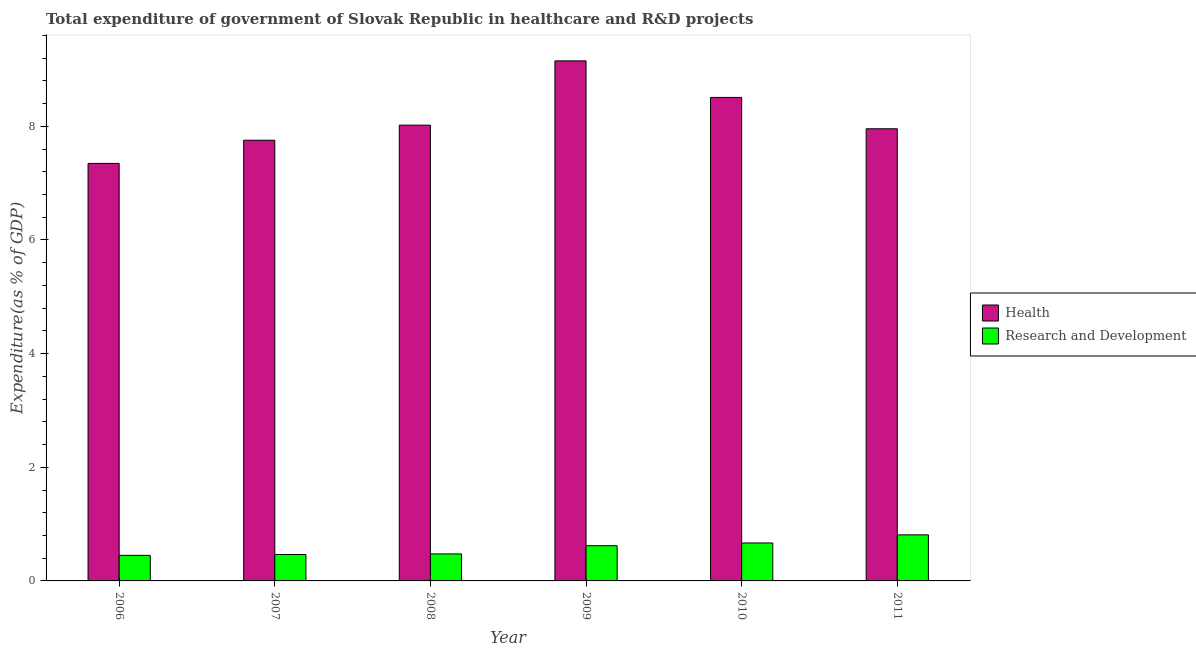How many groups of bars are there?
Offer a very short reply. 6. Are the number of bars on each tick of the X-axis equal?
Offer a very short reply. Yes. How many bars are there on the 2nd tick from the right?
Offer a terse response. 2. What is the label of the 4th group of bars from the left?
Give a very brief answer. 2009. In how many cases, is the number of bars for a given year not equal to the number of legend labels?
Keep it short and to the point. 0. What is the expenditure in healthcare in 2010?
Provide a succinct answer. 8.51. Across all years, what is the maximum expenditure in r&d?
Provide a succinct answer. 0.81. Across all years, what is the minimum expenditure in r&d?
Your answer should be compact. 0.45. In which year was the expenditure in healthcare maximum?
Provide a succinct answer. 2009. In which year was the expenditure in healthcare minimum?
Provide a succinct answer. 2006. What is the total expenditure in healthcare in the graph?
Ensure brevity in your answer.  48.74. What is the difference between the expenditure in r&d in 2007 and that in 2010?
Ensure brevity in your answer.  -0.2. What is the difference between the expenditure in healthcare in 2010 and the expenditure in r&d in 2006?
Offer a very short reply. 1.16. What is the average expenditure in healthcare per year?
Make the answer very short. 8.12. In the year 2009, what is the difference between the expenditure in healthcare and expenditure in r&d?
Ensure brevity in your answer.  0. What is the ratio of the expenditure in r&d in 2007 to that in 2011?
Keep it short and to the point. 0.57. Is the difference between the expenditure in healthcare in 2008 and 2010 greater than the difference between the expenditure in r&d in 2008 and 2010?
Your answer should be compact. No. What is the difference between the highest and the second highest expenditure in healthcare?
Give a very brief answer. 0.64. What is the difference between the highest and the lowest expenditure in healthcare?
Provide a short and direct response. 1.8. In how many years, is the expenditure in healthcare greater than the average expenditure in healthcare taken over all years?
Your answer should be compact. 2. What does the 1st bar from the left in 2008 represents?
Offer a terse response. Health. What does the 1st bar from the right in 2009 represents?
Give a very brief answer. Research and Development. How many bars are there?
Ensure brevity in your answer.  12. Are all the bars in the graph horizontal?
Offer a terse response. No. How many years are there in the graph?
Your response must be concise. 6. Does the graph contain any zero values?
Your answer should be compact. No. Where does the legend appear in the graph?
Your answer should be compact. Center right. How many legend labels are there?
Your response must be concise. 2. How are the legend labels stacked?
Your answer should be compact. Vertical. What is the title of the graph?
Keep it short and to the point. Total expenditure of government of Slovak Republic in healthcare and R&D projects. What is the label or title of the X-axis?
Keep it short and to the point. Year. What is the label or title of the Y-axis?
Your answer should be very brief. Expenditure(as % of GDP). What is the Expenditure(as % of GDP) of Health in 2006?
Provide a short and direct response. 7.35. What is the Expenditure(as % of GDP) of Research and Development in 2006?
Offer a very short reply. 0.45. What is the Expenditure(as % of GDP) in Health in 2007?
Ensure brevity in your answer.  7.76. What is the Expenditure(as % of GDP) in Research and Development in 2007?
Give a very brief answer. 0.46. What is the Expenditure(as % of GDP) in Health in 2008?
Offer a terse response. 8.02. What is the Expenditure(as % of GDP) of Research and Development in 2008?
Your answer should be very brief. 0.47. What is the Expenditure(as % of GDP) of Health in 2009?
Give a very brief answer. 9.15. What is the Expenditure(as % of GDP) of Research and Development in 2009?
Offer a terse response. 0.62. What is the Expenditure(as % of GDP) of Health in 2010?
Your answer should be very brief. 8.51. What is the Expenditure(as % of GDP) of Research and Development in 2010?
Your answer should be very brief. 0.67. What is the Expenditure(as % of GDP) in Health in 2011?
Your response must be concise. 7.96. What is the Expenditure(as % of GDP) of Research and Development in 2011?
Give a very brief answer. 0.81. Across all years, what is the maximum Expenditure(as % of GDP) of Health?
Your answer should be compact. 9.15. Across all years, what is the maximum Expenditure(as % of GDP) in Research and Development?
Your answer should be compact. 0.81. Across all years, what is the minimum Expenditure(as % of GDP) of Health?
Ensure brevity in your answer.  7.35. Across all years, what is the minimum Expenditure(as % of GDP) in Research and Development?
Give a very brief answer. 0.45. What is the total Expenditure(as % of GDP) of Health in the graph?
Offer a terse response. 48.74. What is the total Expenditure(as % of GDP) of Research and Development in the graph?
Provide a succinct answer. 3.49. What is the difference between the Expenditure(as % of GDP) of Health in 2006 and that in 2007?
Give a very brief answer. -0.41. What is the difference between the Expenditure(as % of GDP) of Research and Development in 2006 and that in 2007?
Ensure brevity in your answer.  -0.01. What is the difference between the Expenditure(as % of GDP) of Health in 2006 and that in 2008?
Ensure brevity in your answer.  -0.67. What is the difference between the Expenditure(as % of GDP) in Research and Development in 2006 and that in 2008?
Keep it short and to the point. -0.03. What is the difference between the Expenditure(as % of GDP) of Health in 2006 and that in 2009?
Your answer should be very brief. -1.8. What is the difference between the Expenditure(as % of GDP) of Research and Development in 2006 and that in 2009?
Your response must be concise. -0.17. What is the difference between the Expenditure(as % of GDP) in Health in 2006 and that in 2010?
Make the answer very short. -1.16. What is the difference between the Expenditure(as % of GDP) in Research and Development in 2006 and that in 2010?
Your response must be concise. -0.22. What is the difference between the Expenditure(as % of GDP) of Health in 2006 and that in 2011?
Ensure brevity in your answer.  -0.61. What is the difference between the Expenditure(as % of GDP) of Research and Development in 2006 and that in 2011?
Keep it short and to the point. -0.36. What is the difference between the Expenditure(as % of GDP) in Health in 2007 and that in 2008?
Keep it short and to the point. -0.27. What is the difference between the Expenditure(as % of GDP) of Research and Development in 2007 and that in 2008?
Provide a short and direct response. -0.01. What is the difference between the Expenditure(as % of GDP) in Health in 2007 and that in 2009?
Your answer should be compact. -1.4. What is the difference between the Expenditure(as % of GDP) in Research and Development in 2007 and that in 2009?
Your answer should be compact. -0.16. What is the difference between the Expenditure(as % of GDP) in Health in 2007 and that in 2010?
Give a very brief answer. -0.75. What is the difference between the Expenditure(as % of GDP) of Research and Development in 2007 and that in 2010?
Ensure brevity in your answer.  -0.2. What is the difference between the Expenditure(as % of GDP) of Health in 2007 and that in 2011?
Your response must be concise. -0.2. What is the difference between the Expenditure(as % of GDP) of Research and Development in 2007 and that in 2011?
Make the answer very short. -0.35. What is the difference between the Expenditure(as % of GDP) in Health in 2008 and that in 2009?
Give a very brief answer. -1.13. What is the difference between the Expenditure(as % of GDP) of Research and Development in 2008 and that in 2009?
Give a very brief answer. -0.14. What is the difference between the Expenditure(as % of GDP) of Health in 2008 and that in 2010?
Provide a short and direct response. -0.49. What is the difference between the Expenditure(as % of GDP) of Research and Development in 2008 and that in 2010?
Your answer should be compact. -0.19. What is the difference between the Expenditure(as % of GDP) in Health in 2008 and that in 2011?
Provide a succinct answer. 0.06. What is the difference between the Expenditure(as % of GDP) in Research and Development in 2008 and that in 2011?
Provide a succinct answer. -0.34. What is the difference between the Expenditure(as % of GDP) in Health in 2009 and that in 2010?
Provide a short and direct response. 0.64. What is the difference between the Expenditure(as % of GDP) of Research and Development in 2009 and that in 2010?
Ensure brevity in your answer.  -0.05. What is the difference between the Expenditure(as % of GDP) in Health in 2009 and that in 2011?
Offer a terse response. 1.19. What is the difference between the Expenditure(as % of GDP) of Research and Development in 2009 and that in 2011?
Make the answer very short. -0.19. What is the difference between the Expenditure(as % of GDP) of Health in 2010 and that in 2011?
Make the answer very short. 0.55. What is the difference between the Expenditure(as % of GDP) of Research and Development in 2010 and that in 2011?
Ensure brevity in your answer.  -0.14. What is the difference between the Expenditure(as % of GDP) in Health in 2006 and the Expenditure(as % of GDP) in Research and Development in 2007?
Provide a succinct answer. 6.88. What is the difference between the Expenditure(as % of GDP) of Health in 2006 and the Expenditure(as % of GDP) of Research and Development in 2008?
Your response must be concise. 6.87. What is the difference between the Expenditure(as % of GDP) in Health in 2006 and the Expenditure(as % of GDP) in Research and Development in 2009?
Your response must be concise. 6.73. What is the difference between the Expenditure(as % of GDP) in Health in 2006 and the Expenditure(as % of GDP) in Research and Development in 2010?
Give a very brief answer. 6.68. What is the difference between the Expenditure(as % of GDP) of Health in 2006 and the Expenditure(as % of GDP) of Research and Development in 2011?
Keep it short and to the point. 6.54. What is the difference between the Expenditure(as % of GDP) of Health in 2007 and the Expenditure(as % of GDP) of Research and Development in 2008?
Your response must be concise. 7.28. What is the difference between the Expenditure(as % of GDP) in Health in 2007 and the Expenditure(as % of GDP) in Research and Development in 2009?
Your answer should be very brief. 7.14. What is the difference between the Expenditure(as % of GDP) in Health in 2007 and the Expenditure(as % of GDP) in Research and Development in 2010?
Provide a short and direct response. 7.09. What is the difference between the Expenditure(as % of GDP) in Health in 2007 and the Expenditure(as % of GDP) in Research and Development in 2011?
Your answer should be compact. 6.94. What is the difference between the Expenditure(as % of GDP) of Health in 2008 and the Expenditure(as % of GDP) of Research and Development in 2009?
Ensure brevity in your answer.  7.4. What is the difference between the Expenditure(as % of GDP) of Health in 2008 and the Expenditure(as % of GDP) of Research and Development in 2010?
Keep it short and to the point. 7.35. What is the difference between the Expenditure(as % of GDP) of Health in 2008 and the Expenditure(as % of GDP) of Research and Development in 2011?
Give a very brief answer. 7.21. What is the difference between the Expenditure(as % of GDP) in Health in 2009 and the Expenditure(as % of GDP) in Research and Development in 2010?
Your response must be concise. 8.48. What is the difference between the Expenditure(as % of GDP) in Health in 2009 and the Expenditure(as % of GDP) in Research and Development in 2011?
Offer a terse response. 8.34. What is the difference between the Expenditure(as % of GDP) of Health in 2010 and the Expenditure(as % of GDP) of Research and Development in 2011?
Your response must be concise. 7.7. What is the average Expenditure(as % of GDP) in Health per year?
Offer a terse response. 8.12. What is the average Expenditure(as % of GDP) in Research and Development per year?
Give a very brief answer. 0.58. In the year 2006, what is the difference between the Expenditure(as % of GDP) of Health and Expenditure(as % of GDP) of Research and Development?
Your answer should be very brief. 6.9. In the year 2007, what is the difference between the Expenditure(as % of GDP) of Health and Expenditure(as % of GDP) of Research and Development?
Provide a succinct answer. 7.29. In the year 2008, what is the difference between the Expenditure(as % of GDP) in Health and Expenditure(as % of GDP) in Research and Development?
Ensure brevity in your answer.  7.55. In the year 2009, what is the difference between the Expenditure(as % of GDP) in Health and Expenditure(as % of GDP) in Research and Development?
Offer a very short reply. 8.53. In the year 2010, what is the difference between the Expenditure(as % of GDP) in Health and Expenditure(as % of GDP) in Research and Development?
Your answer should be very brief. 7.84. In the year 2011, what is the difference between the Expenditure(as % of GDP) of Health and Expenditure(as % of GDP) of Research and Development?
Ensure brevity in your answer.  7.15. What is the ratio of the Expenditure(as % of GDP) of Health in 2006 to that in 2007?
Your answer should be compact. 0.95. What is the ratio of the Expenditure(as % of GDP) in Research and Development in 2006 to that in 2007?
Offer a very short reply. 0.97. What is the ratio of the Expenditure(as % of GDP) in Health in 2006 to that in 2008?
Keep it short and to the point. 0.92. What is the ratio of the Expenditure(as % of GDP) in Research and Development in 2006 to that in 2008?
Your answer should be compact. 0.95. What is the ratio of the Expenditure(as % of GDP) in Health in 2006 to that in 2009?
Make the answer very short. 0.8. What is the ratio of the Expenditure(as % of GDP) in Research and Development in 2006 to that in 2009?
Keep it short and to the point. 0.73. What is the ratio of the Expenditure(as % of GDP) in Health in 2006 to that in 2010?
Make the answer very short. 0.86. What is the ratio of the Expenditure(as % of GDP) of Research and Development in 2006 to that in 2010?
Make the answer very short. 0.67. What is the ratio of the Expenditure(as % of GDP) of Health in 2006 to that in 2011?
Your answer should be compact. 0.92. What is the ratio of the Expenditure(as % of GDP) in Research and Development in 2006 to that in 2011?
Give a very brief answer. 0.55. What is the ratio of the Expenditure(as % of GDP) in Health in 2007 to that in 2008?
Ensure brevity in your answer.  0.97. What is the ratio of the Expenditure(as % of GDP) of Research and Development in 2007 to that in 2008?
Provide a succinct answer. 0.98. What is the ratio of the Expenditure(as % of GDP) of Health in 2007 to that in 2009?
Provide a succinct answer. 0.85. What is the ratio of the Expenditure(as % of GDP) in Research and Development in 2007 to that in 2009?
Your answer should be very brief. 0.75. What is the ratio of the Expenditure(as % of GDP) of Health in 2007 to that in 2010?
Offer a terse response. 0.91. What is the ratio of the Expenditure(as % of GDP) in Research and Development in 2007 to that in 2010?
Ensure brevity in your answer.  0.7. What is the ratio of the Expenditure(as % of GDP) in Health in 2007 to that in 2011?
Your answer should be very brief. 0.97. What is the ratio of the Expenditure(as % of GDP) in Research and Development in 2007 to that in 2011?
Provide a succinct answer. 0.57. What is the ratio of the Expenditure(as % of GDP) in Health in 2008 to that in 2009?
Make the answer very short. 0.88. What is the ratio of the Expenditure(as % of GDP) of Research and Development in 2008 to that in 2009?
Your response must be concise. 0.77. What is the ratio of the Expenditure(as % of GDP) in Health in 2008 to that in 2010?
Keep it short and to the point. 0.94. What is the ratio of the Expenditure(as % of GDP) in Research and Development in 2008 to that in 2010?
Offer a terse response. 0.71. What is the ratio of the Expenditure(as % of GDP) in Health in 2008 to that in 2011?
Keep it short and to the point. 1.01. What is the ratio of the Expenditure(as % of GDP) of Research and Development in 2008 to that in 2011?
Your answer should be compact. 0.59. What is the ratio of the Expenditure(as % of GDP) in Health in 2009 to that in 2010?
Provide a succinct answer. 1.08. What is the ratio of the Expenditure(as % of GDP) of Research and Development in 2009 to that in 2010?
Keep it short and to the point. 0.93. What is the ratio of the Expenditure(as % of GDP) of Health in 2009 to that in 2011?
Offer a very short reply. 1.15. What is the ratio of the Expenditure(as % of GDP) of Research and Development in 2009 to that in 2011?
Offer a terse response. 0.76. What is the ratio of the Expenditure(as % of GDP) in Health in 2010 to that in 2011?
Keep it short and to the point. 1.07. What is the ratio of the Expenditure(as % of GDP) of Research and Development in 2010 to that in 2011?
Your answer should be compact. 0.82. What is the difference between the highest and the second highest Expenditure(as % of GDP) in Health?
Ensure brevity in your answer.  0.64. What is the difference between the highest and the second highest Expenditure(as % of GDP) in Research and Development?
Offer a very short reply. 0.14. What is the difference between the highest and the lowest Expenditure(as % of GDP) in Health?
Give a very brief answer. 1.8. What is the difference between the highest and the lowest Expenditure(as % of GDP) in Research and Development?
Make the answer very short. 0.36. 